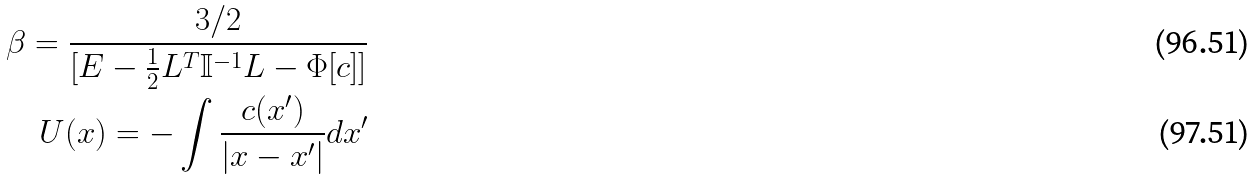<formula> <loc_0><loc_0><loc_500><loc_500>\beta = \frac { 3 / 2 } { [ E - \frac { 1 } { 2 } L ^ { T } \mathbb { I } ^ { - 1 } L - \Phi [ c ] ] } \\ U ( x ) = - \int \frac { c ( x ^ { \prime } ) } { | x - x ^ { \prime } | } d x ^ { \prime }</formula> 